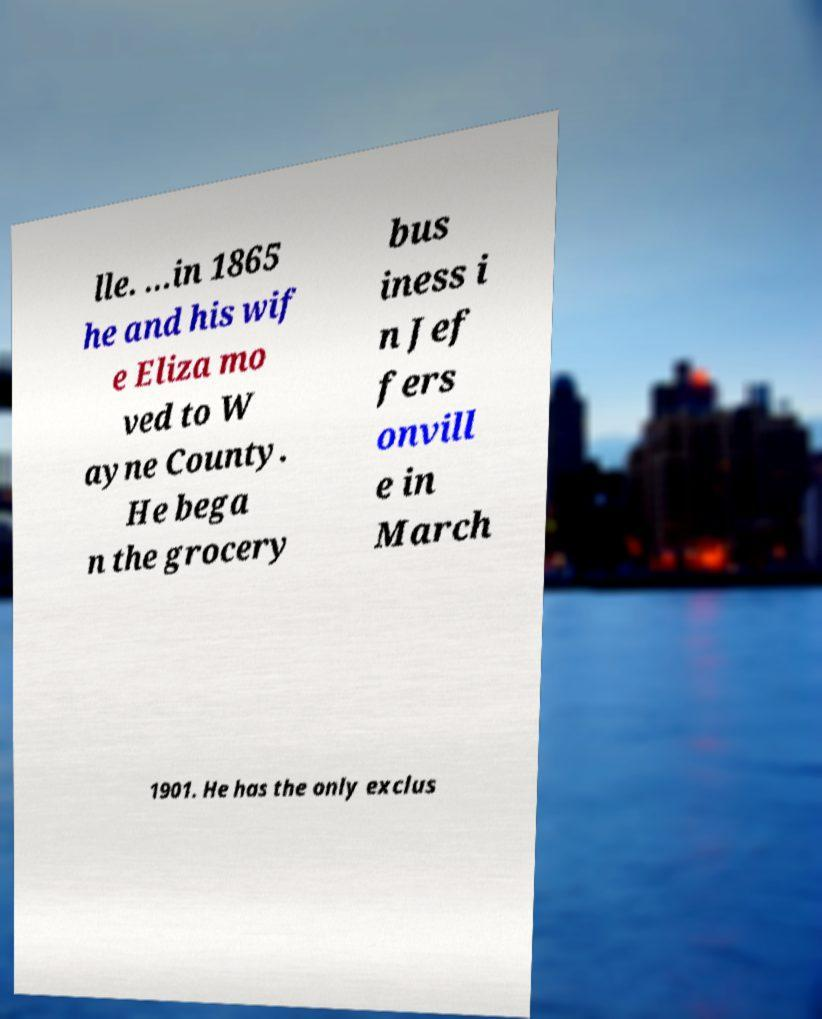Could you extract and type out the text from this image? lle. ...in 1865 he and his wif e Eliza mo ved to W ayne County. He bega n the grocery bus iness i n Jef fers onvill e in March 1901. He has the only exclus 